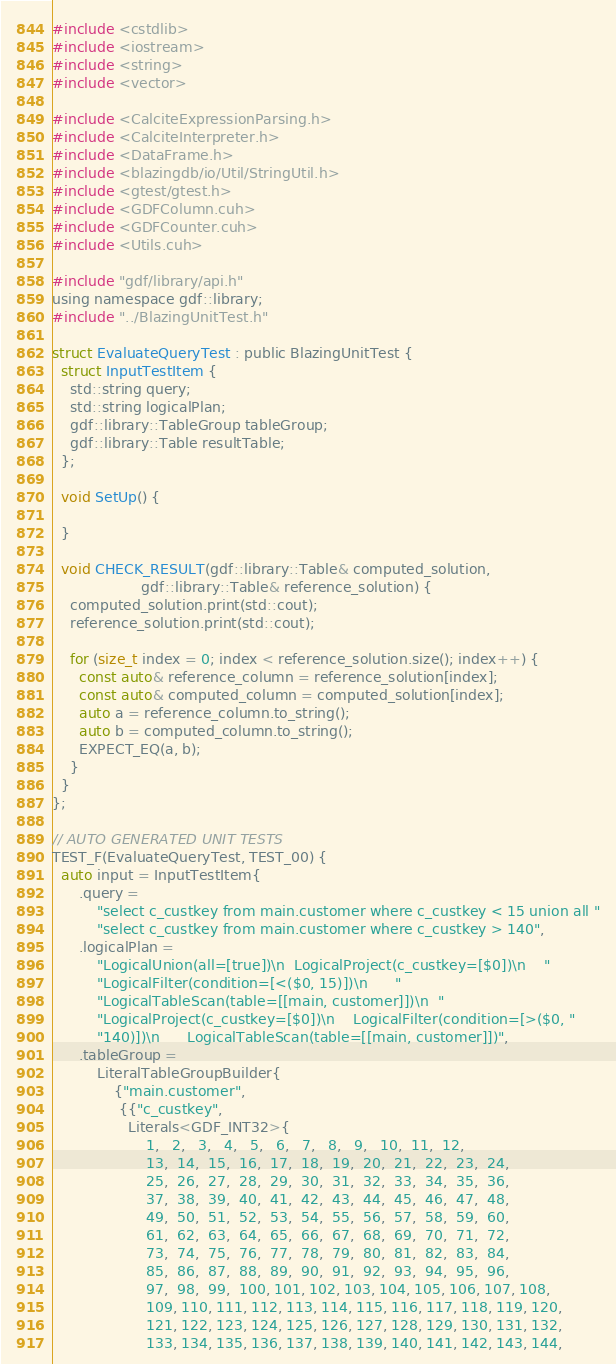Convert code to text. <code><loc_0><loc_0><loc_500><loc_500><_Cuda_>
#include <cstdlib>
#include <iostream>
#include <string>
#include <vector>

#include <CalciteExpressionParsing.h>
#include <CalciteInterpreter.h>
#include <DataFrame.h>
#include <blazingdb/io/Util/StringUtil.h>
#include <gtest/gtest.h>
#include <GDFColumn.cuh>
#include <GDFCounter.cuh>
#include <Utils.cuh>

#include "gdf/library/api.h"
using namespace gdf::library;
#include "../BlazingUnitTest.h"

struct EvaluateQueryTest : public BlazingUnitTest {
  struct InputTestItem {
    std::string query;
    std::string logicalPlan;
    gdf::library::TableGroup tableGroup;
    gdf::library::Table resultTable;
  };

  void SetUp() {
    
  }

  void CHECK_RESULT(gdf::library::Table& computed_solution,
                    gdf::library::Table& reference_solution) {
    computed_solution.print(std::cout);
    reference_solution.print(std::cout);

    for (size_t index = 0; index < reference_solution.size(); index++) {
      const auto& reference_column = reference_solution[index];
      const auto& computed_column = computed_solution[index];
      auto a = reference_column.to_string();
      auto b = computed_column.to_string();
      EXPECT_EQ(a, b);
    }
  }
};

// AUTO GENERATED UNIT TESTS
TEST_F(EvaluateQueryTest, TEST_00) {
  auto input = InputTestItem{
      .query =
          "select c_custkey from main.customer where c_custkey < 15 union all "
          "select c_custkey from main.customer where c_custkey > 140",
      .logicalPlan =
          "LogicalUnion(all=[true])\n  LogicalProject(c_custkey=[$0])\n    "
          "LogicalFilter(condition=[<($0, 15)])\n      "
          "LogicalTableScan(table=[[main, customer]])\n  "
          "LogicalProject(c_custkey=[$0])\n    LogicalFilter(condition=[>($0, "
          "140)])\n      LogicalTableScan(table=[[main, customer]])",
      .tableGroup =
          LiteralTableGroupBuilder{
              {"main.customer",
               {{"c_custkey",
                 Literals<GDF_INT32>{
                     1,   2,   3,   4,   5,   6,   7,   8,   9,   10,  11,  12,
                     13,  14,  15,  16,  17,  18,  19,  20,  21,  22,  23,  24,
                     25,  26,  27,  28,  29,  30,  31,  32,  33,  34,  35,  36,
                     37,  38,  39,  40,  41,  42,  43,  44,  45,  46,  47,  48,
                     49,  50,  51,  52,  53,  54,  55,  56,  57,  58,  59,  60,
                     61,  62,  63,  64,  65,  66,  67,  68,  69,  70,  71,  72,
                     73,  74,  75,  76,  77,  78,  79,  80,  81,  82,  83,  84,
                     85,  86,  87,  88,  89,  90,  91,  92,  93,  94,  95,  96,
                     97,  98,  99,  100, 101, 102, 103, 104, 105, 106, 107, 108,
                     109, 110, 111, 112, 113, 114, 115, 116, 117, 118, 119, 120,
                     121, 122, 123, 124, 125, 126, 127, 128, 129, 130, 131, 132,
                     133, 134, 135, 136, 137, 138, 139, 140, 141, 142, 143, 144,</code> 